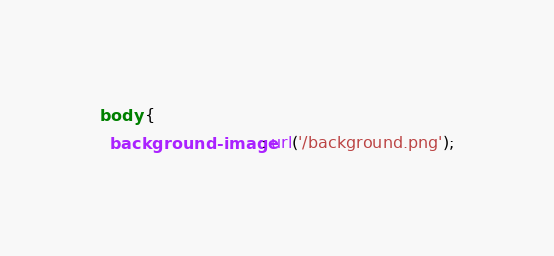Convert code to text. <code><loc_0><loc_0><loc_500><loc_500><_CSS_>body {
  background-image: url('/background.png');</code> 